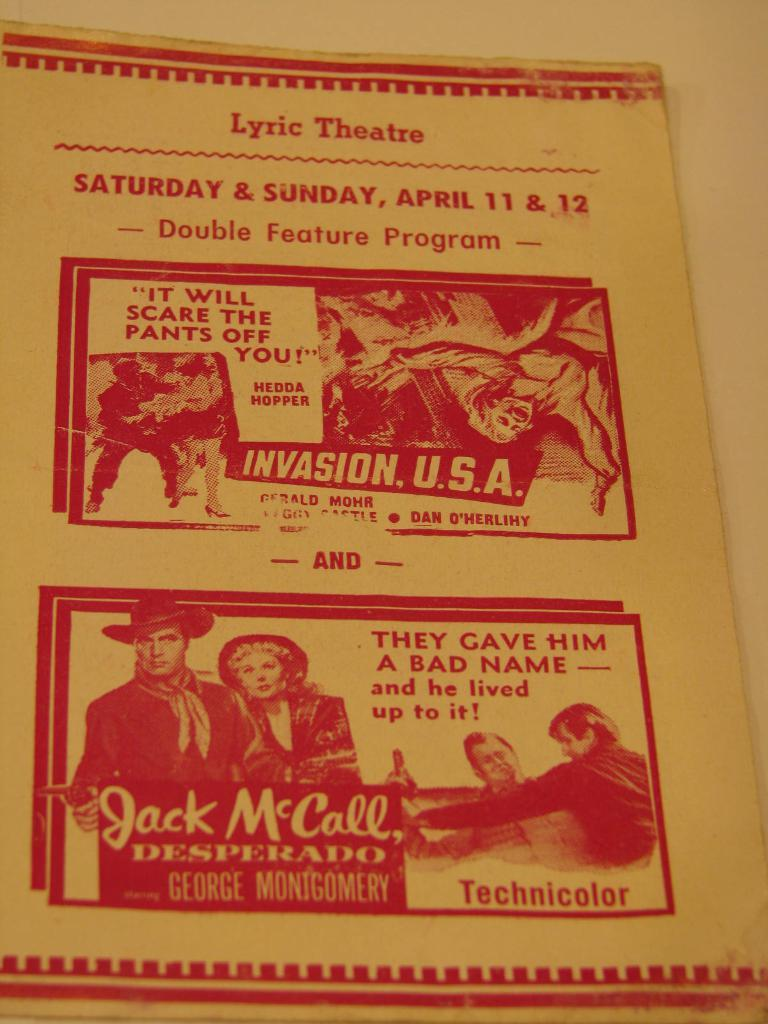<image>
Provide a brief description of the given image. A theatre guide for acts taking place on Saturday and Sunday April 11 and 12. 